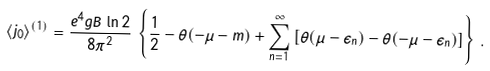<formula> <loc_0><loc_0><loc_500><loc_500>\langle j _ { 0 } \rangle ^ { ( 1 ) } = \frac { e ^ { 4 } g B \, \ln 2 } { 8 \pi ^ { 2 } } \, \left \{ \frac { 1 } { 2 } - \theta ( - \mu - m ) + \sum _ { n = 1 } ^ { \infty } \left [ \theta ( \mu - \epsilon _ { n } ) - \theta ( - \mu - \epsilon _ { n } ) \right ] \right \} \, .</formula> 